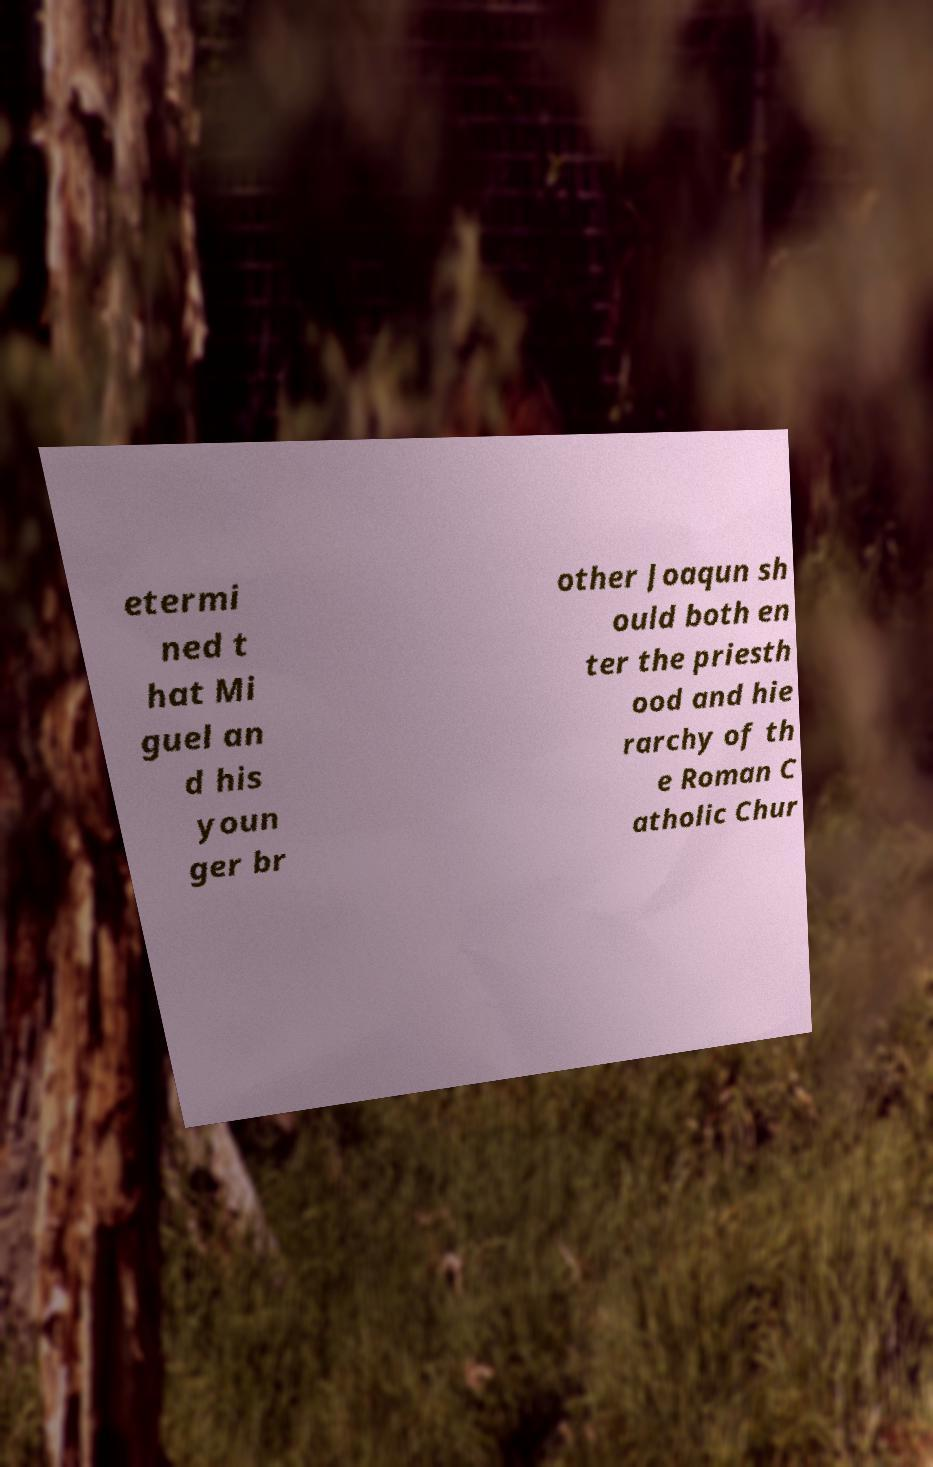There's text embedded in this image that I need extracted. Can you transcribe it verbatim? etermi ned t hat Mi guel an d his youn ger br other Joaqun sh ould both en ter the priesth ood and hie rarchy of th e Roman C atholic Chur 